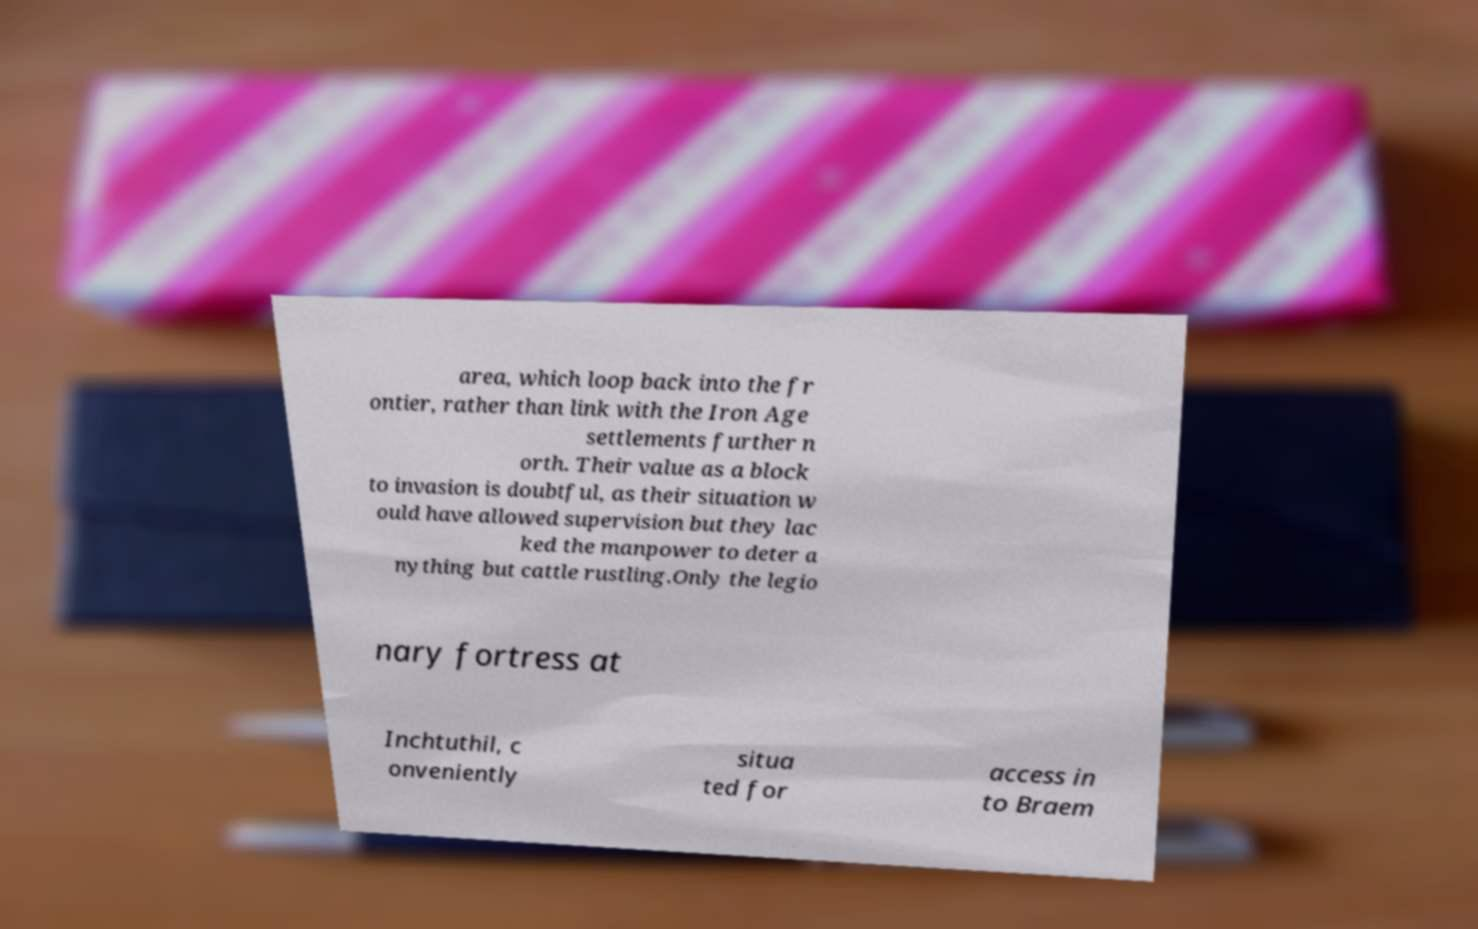Could you assist in decoding the text presented in this image and type it out clearly? area, which loop back into the fr ontier, rather than link with the Iron Age settlements further n orth. Their value as a block to invasion is doubtful, as their situation w ould have allowed supervision but they lac ked the manpower to deter a nything but cattle rustling.Only the legio nary fortress at Inchtuthil, c onveniently situa ted for access in to Braem 